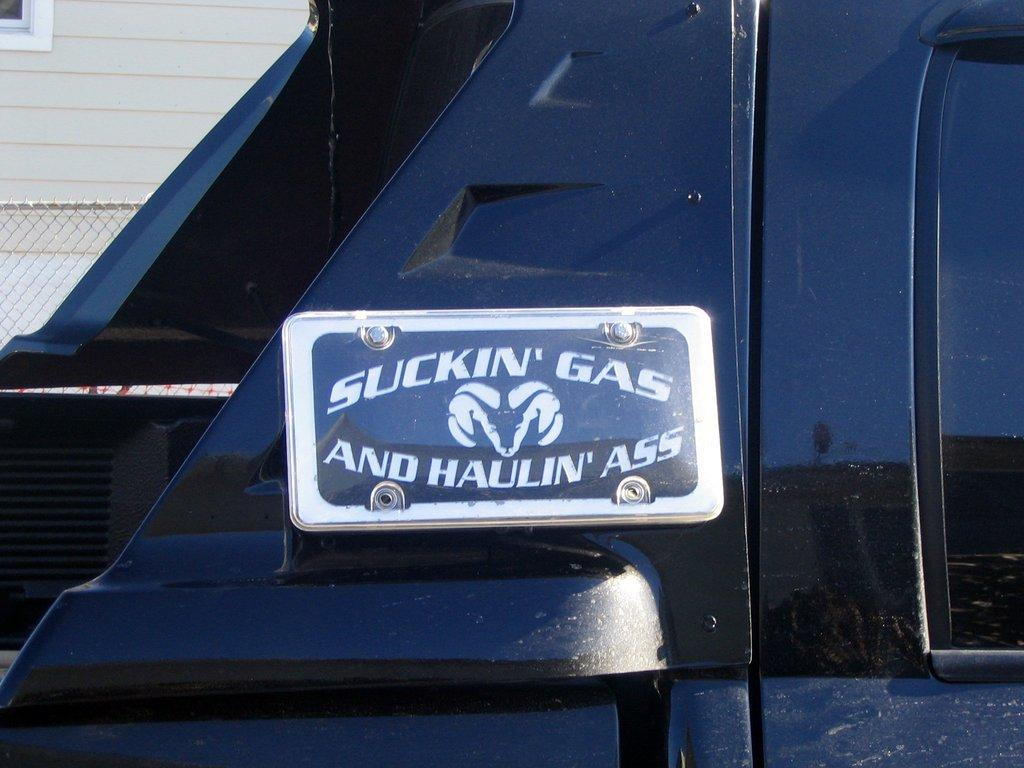What is the main subject of the image? The image might depict a vehicle. What is located in the middle of the image? There is a board in the middle of the image. What type of barrier can be seen in the image? There is fencing in the image. What type of structure is visible in the image? There is a wall in the image. What architectural feature allows for visibility between the inside and outside? There is a window in the image. What type of ant can be seen carrying a rake in the image? There are no ants or rakes present in the image. What word is written on the board in the image? The provided facts do not mention any words on the board, so we cannot determine what word might be written on it. 